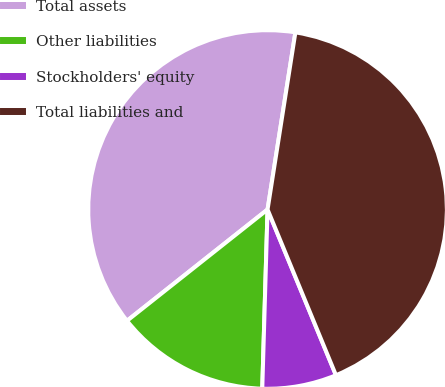<chart> <loc_0><loc_0><loc_500><loc_500><pie_chart><fcel>Total assets<fcel>Other liabilities<fcel>Stockholders' equity<fcel>Total liabilities and<nl><fcel>38.14%<fcel>13.87%<fcel>6.7%<fcel>41.29%<nl></chart> 